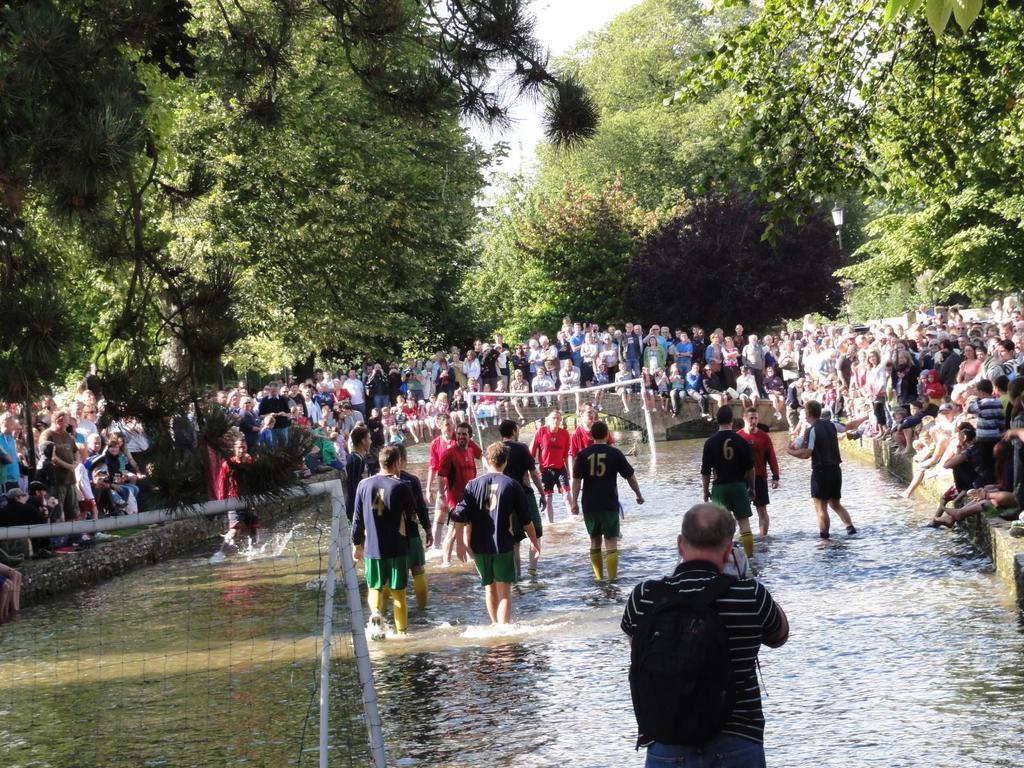How would you summarize this image in a sentence or two? In this image, we can see people in the water and there are nets and one of them is holding a ball and there is a man wearing a bag. In the background, there is a crowd and we can see trees and there are poles. 